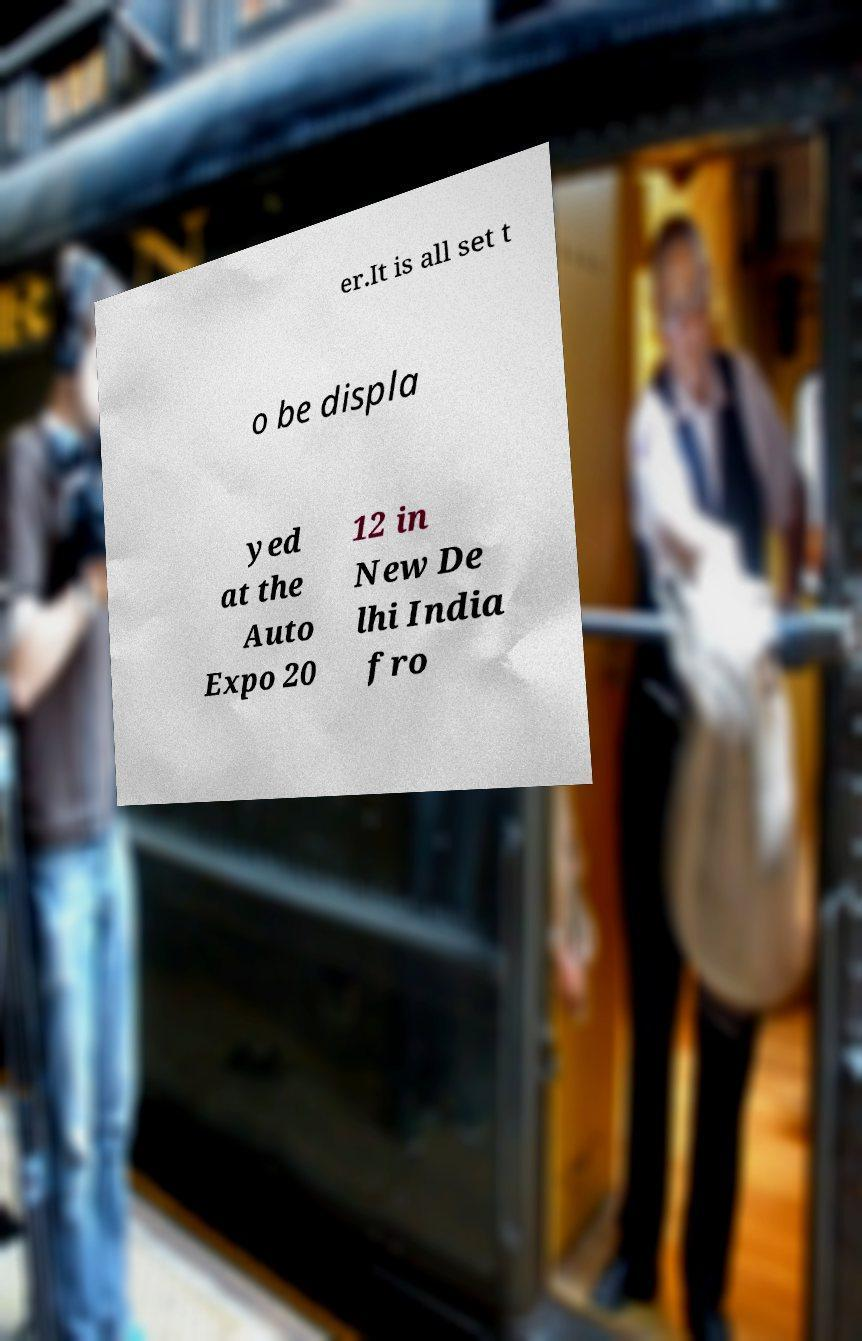Please read and relay the text visible in this image. What does it say? er.It is all set t o be displa yed at the Auto Expo 20 12 in New De lhi India fro 